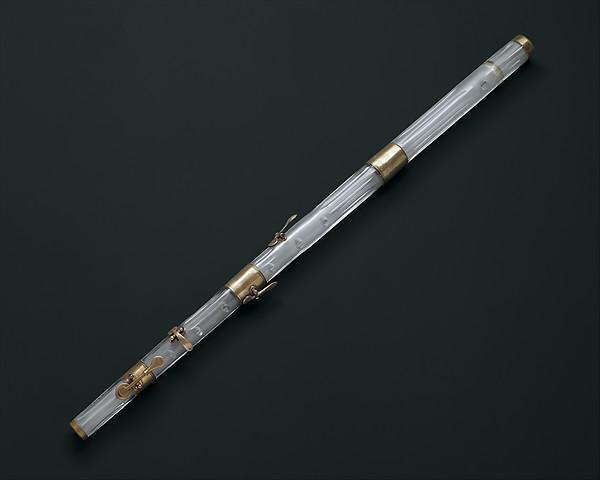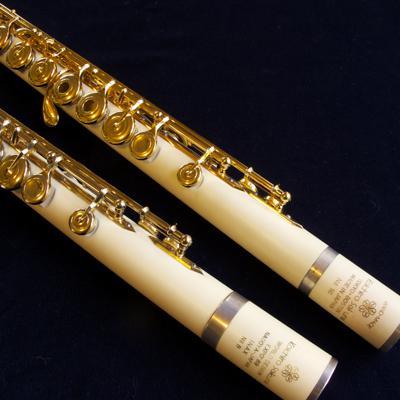The first image is the image on the left, the second image is the image on the right. Considering the images on both sides, is "Two light colored flutes sit side by side." valid? Answer yes or no. Yes. The first image is the image on the left, the second image is the image on the right. For the images shown, is this caption "One image shows a single flute displayed diagonally, and the other image shows at least two flutes displayed right next to each other diagonally." true? Answer yes or no. Yes. 